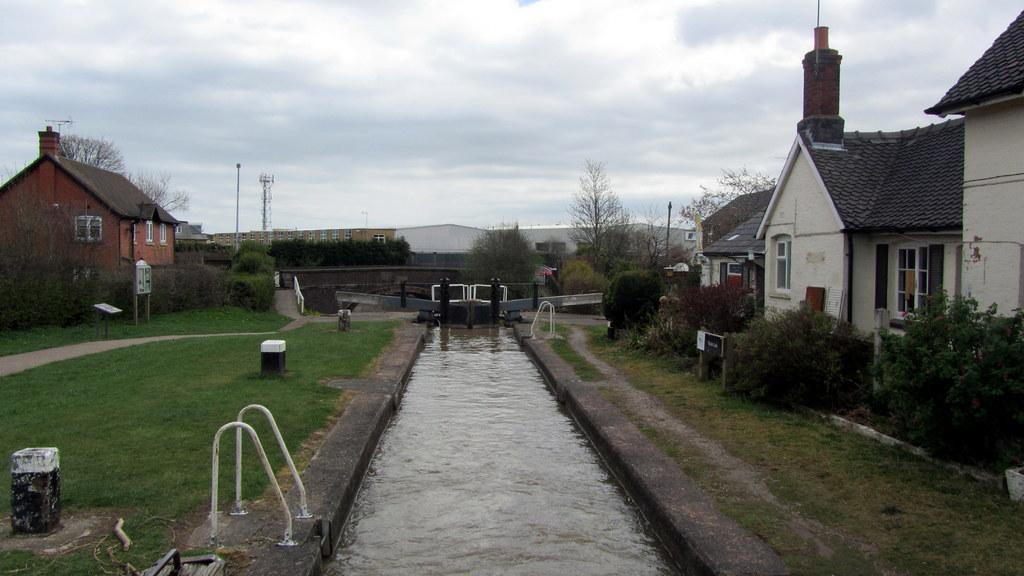In one or two sentences, can you explain what this image depicts? In this image we can see some buildings with windows. We can also see some trees, grass, plants, a fence, some metal poles, water, a tower and the sky which looks cloudy. 